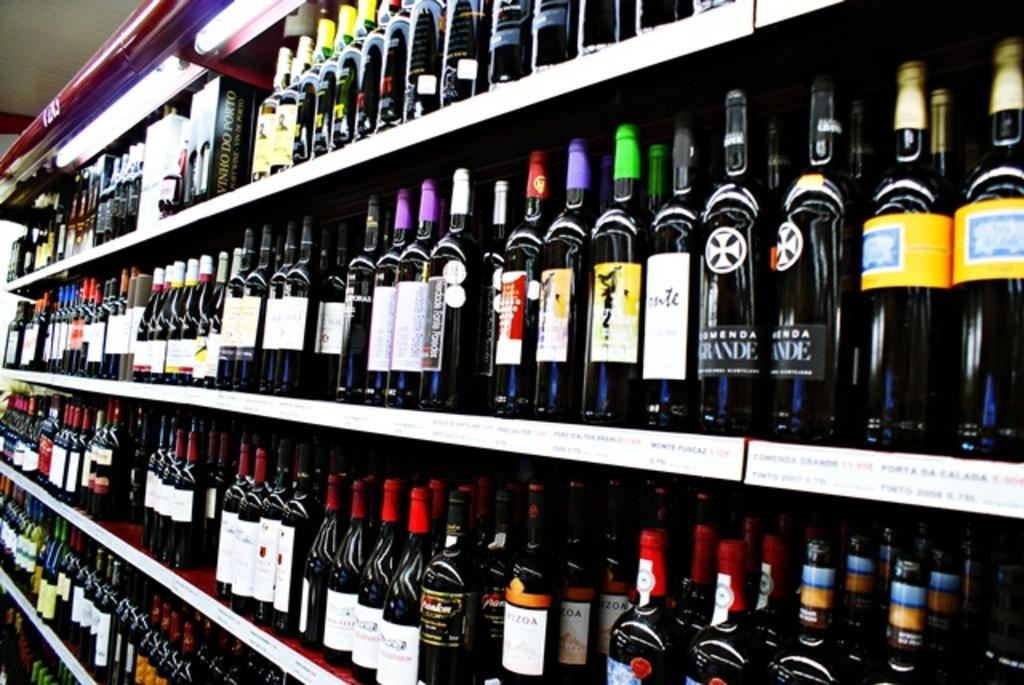<image>
Describe the image concisely. Stocked shelves of bottled alcoholic drinks, in various sizes and brands 